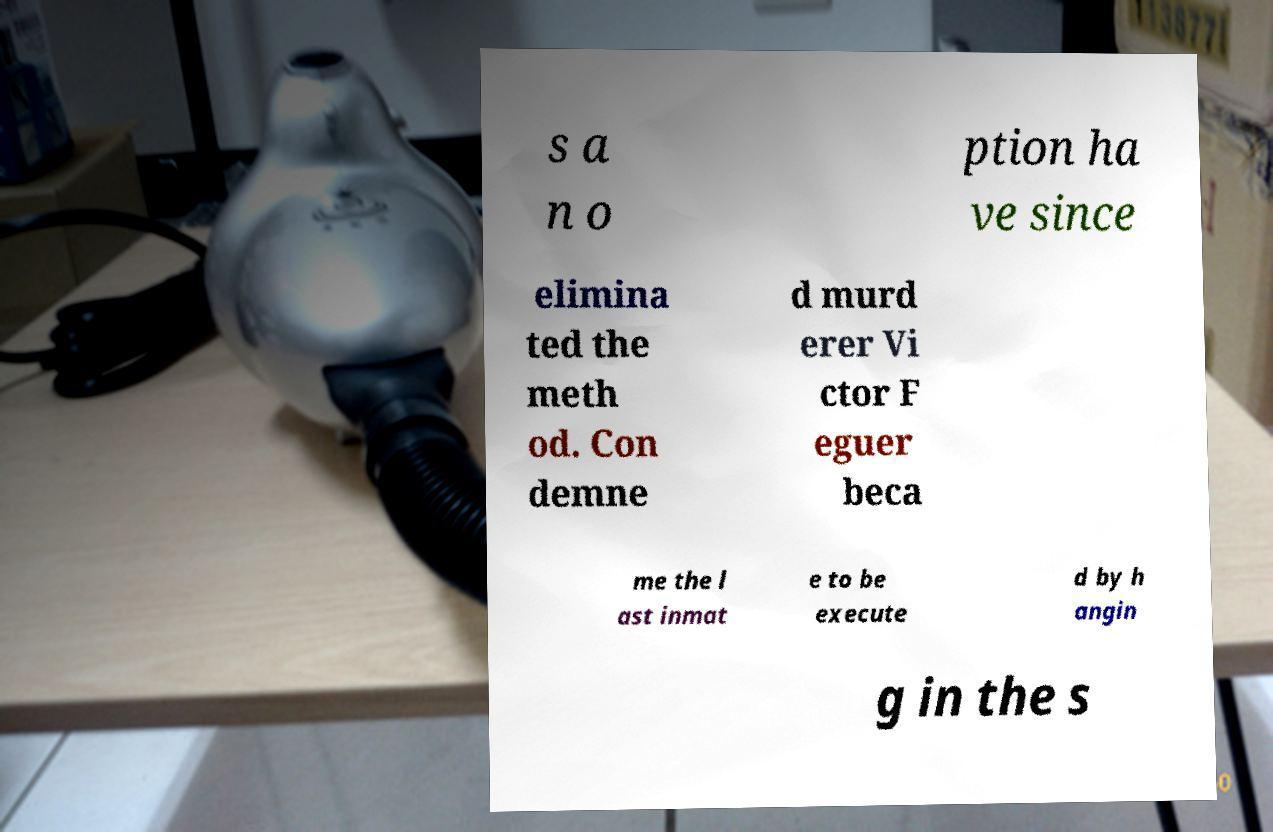For documentation purposes, I need the text within this image transcribed. Could you provide that? s a n o ption ha ve since elimina ted the meth od. Con demne d murd erer Vi ctor F eguer beca me the l ast inmat e to be execute d by h angin g in the s 